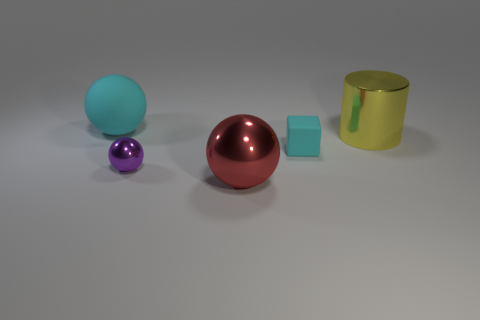What might be the purpose of these objects being grouped together? This composition of objects seems to be constructed for a visual study. It might be used to demonstrate differences in size, color, and reflectivity. Each object also has a distinct shape, which could be relevant in studies of geometry or computer graphics, particularly in the context of rendering techniques or lighting scenarios. 